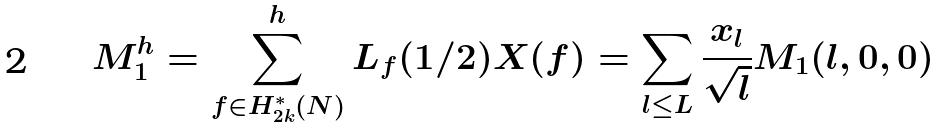<formula> <loc_0><loc_0><loc_500><loc_500>M _ { 1 } ^ { h } = \sum _ { f \in H _ { 2 k } ^ { * } ( N ) } ^ { h } L _ { f } ( 1 / 2 ) X ( f ) = \sum _ { l \leq L } \frac { x _ { l } } { \sqrt { l } } M _ { 1 } ( l , 0 , 0 )</formula> 